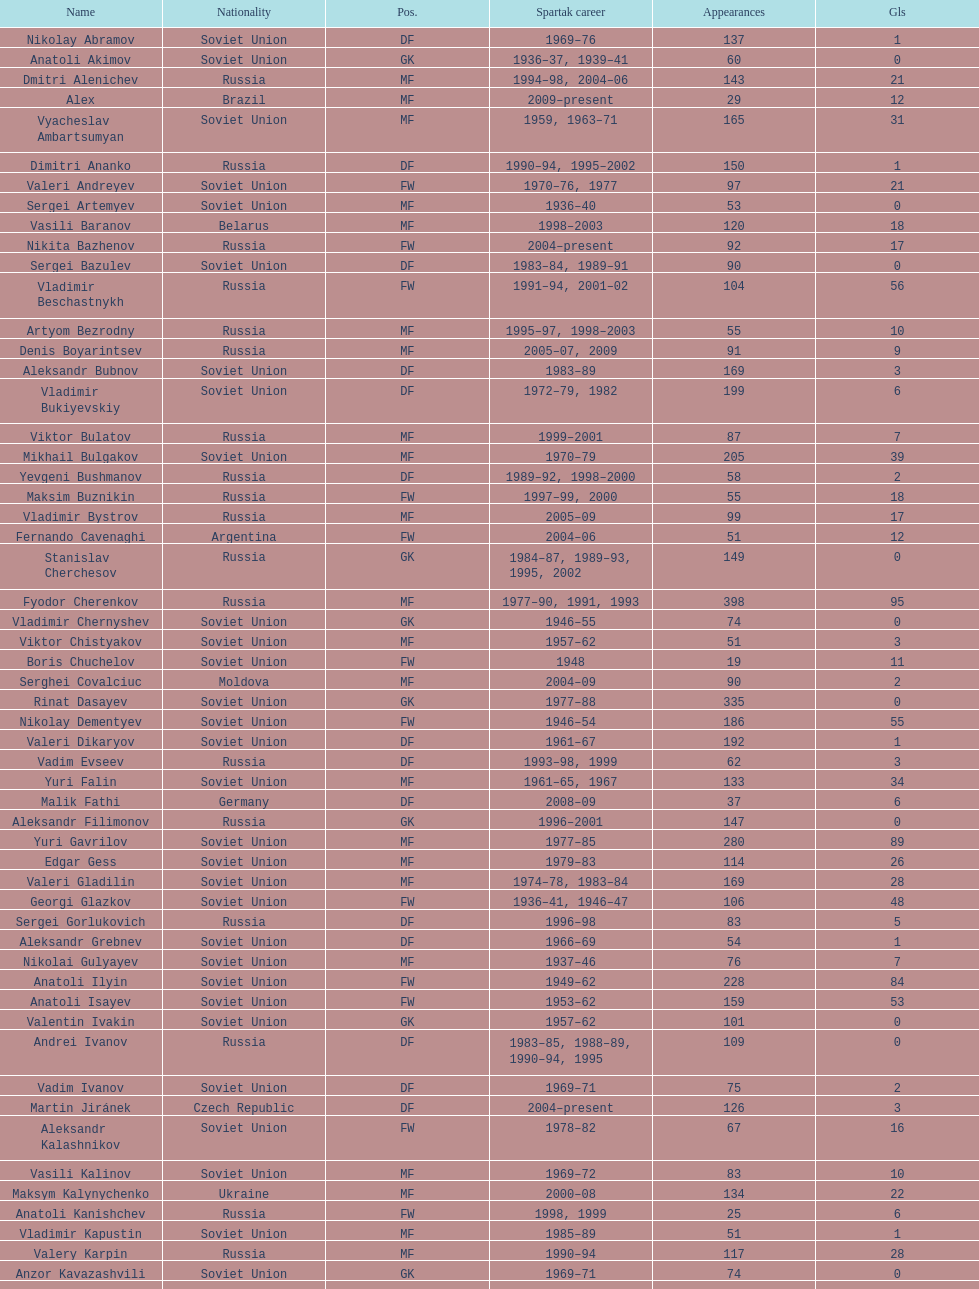Which player has the highest number of goals? Nikita Simonyan. 